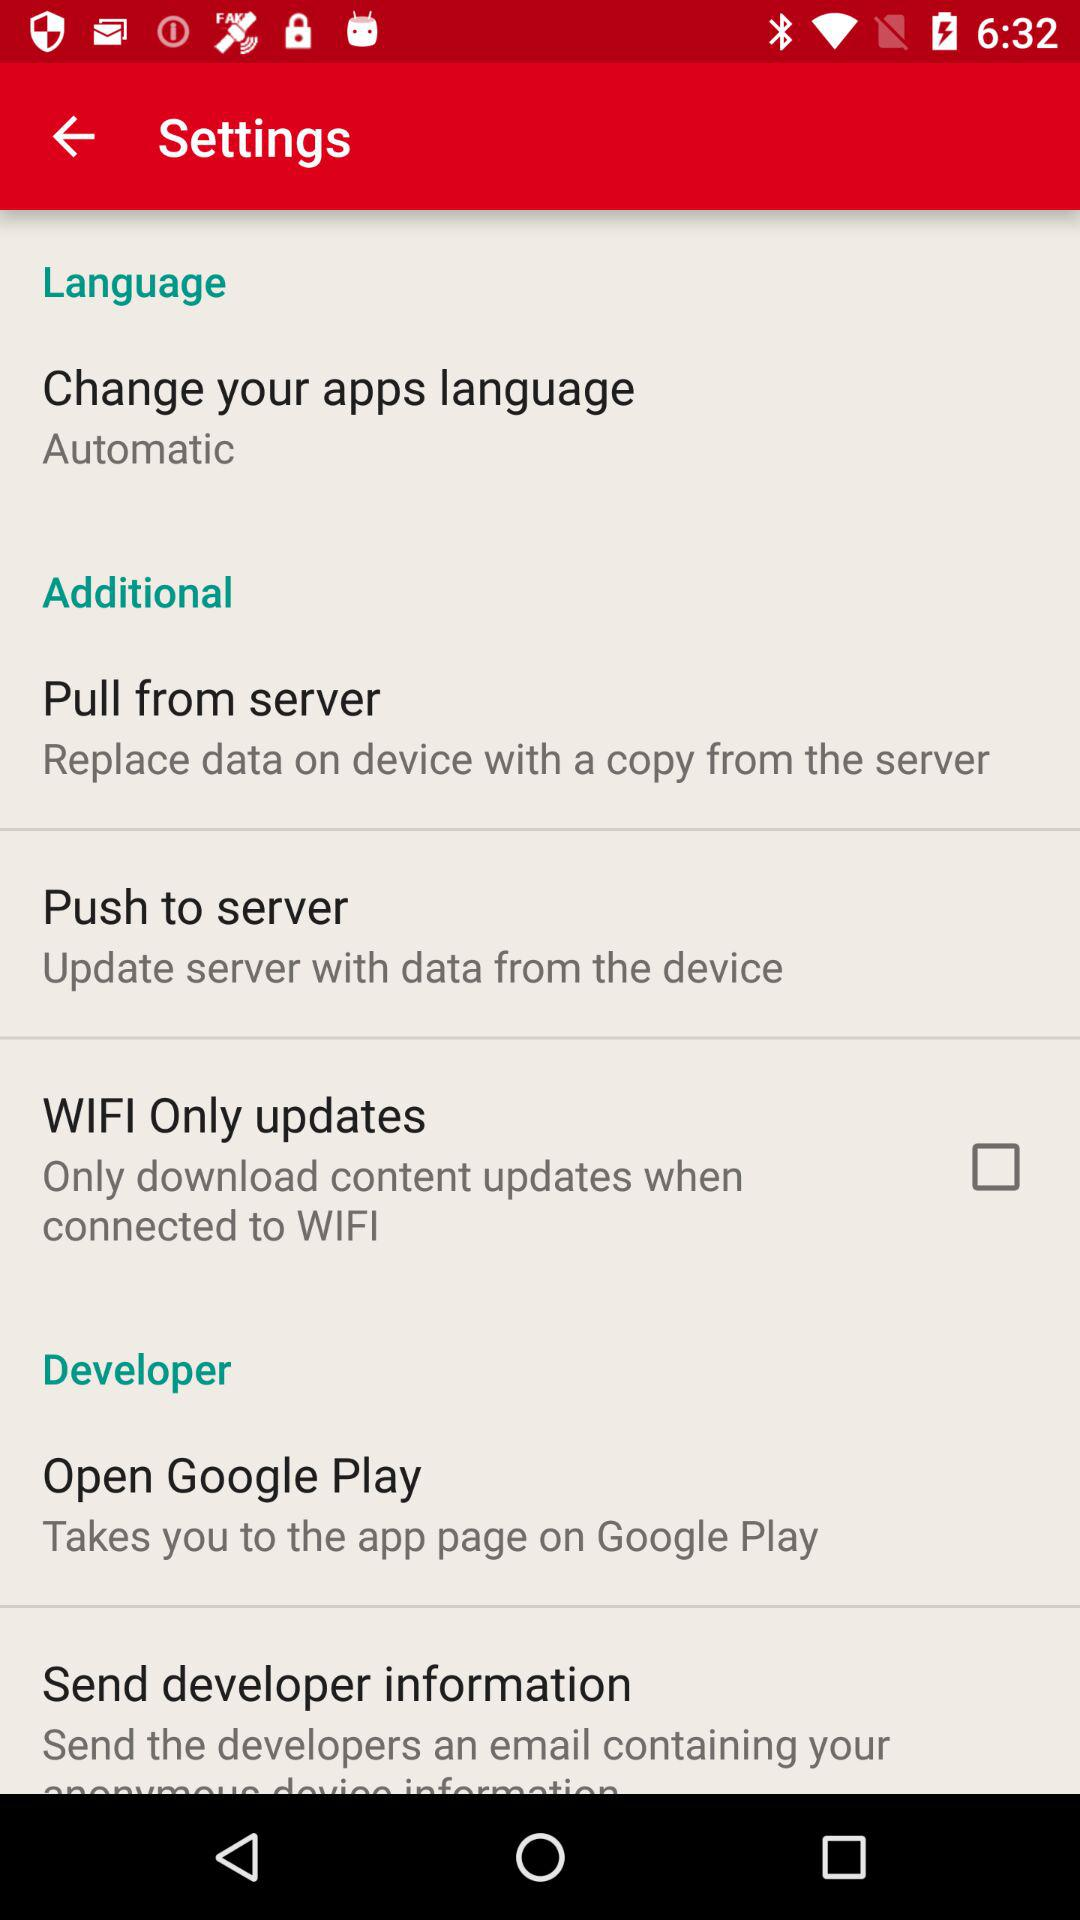What is the status of "WIFI Only updates"? The status of "WIFI Only updates" is "off". 